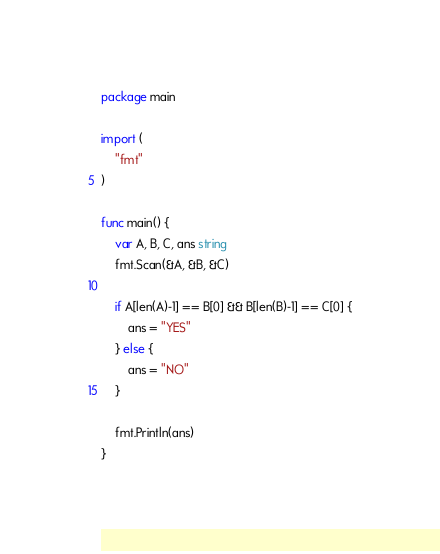<code> <loc_0><loc_0><loc_500><loc_500><_Go_>package main

import (
	"fmt"
)

func main() {
	var A, B, C, ans string
	fmt.Scan(&A, &B, &C)

	if A[len(A)-1] == B[0] && B[len(B)-1] == C[0] {
		ans = "YES"
	} else {
		ans = "NO"
	}

	fmt.Println(ans)
}</code> 